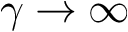Convert formula to latex. <formula><loc_0><loc_0><loc_500><loc_500>\gamma \rightarrow \infty</formula> 